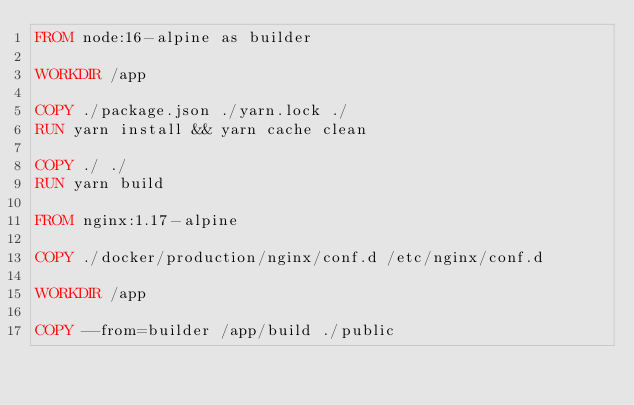Convert code to text. <code><loc_0><loc_0><loc_500><loc_500><_Dockerfile_>FROM node:16-alpine as builder

WORKDIR /app

COPY ./package.json ./yarn.lock ./
RUN yarn install && yarn cache clean

COPY ./ ./
RUN yarn build

FROM nginx:1.17-alpine

COPY ./docker/production/nginx/conf.d /etc/nginx/conf.d

WORKDIR /app

COPY --from=builder /app/build ./public
</code> 